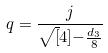Convert formula to latex. <formula><loc_0><loc_0><loc_500><loc_500>q = \frac { j } { \sqrt { [ } 4 ] { - \frac { d _ { 3 } } { 8 } } }</formula> 